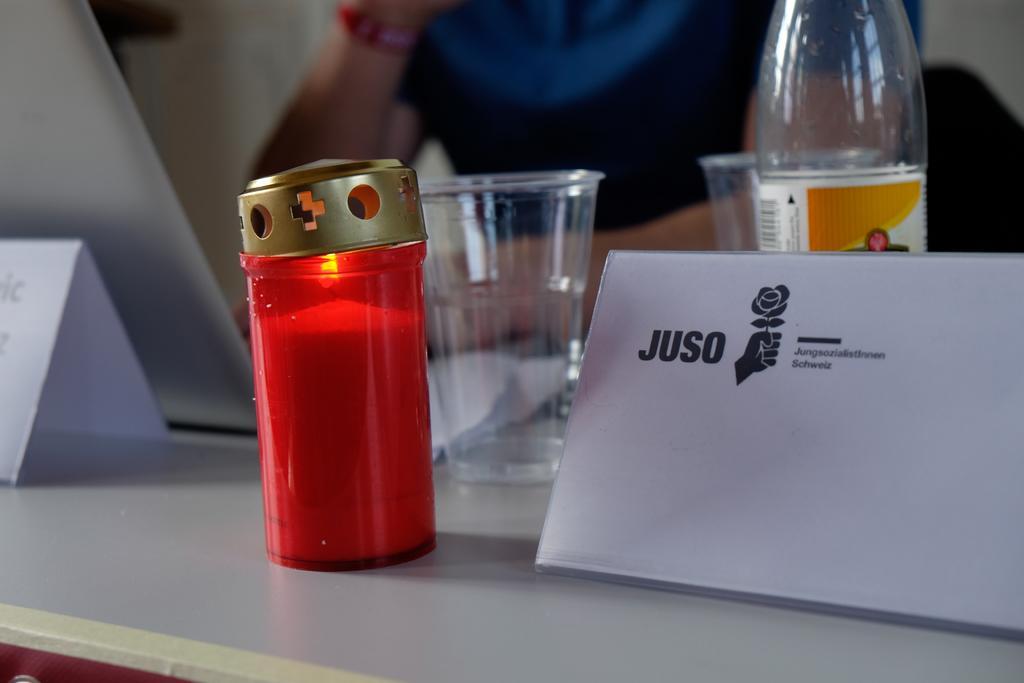Can you describe this image briefly? In this image we can see name boards, disposable tumblers, candle in the candle holder and a disposal bottle. 